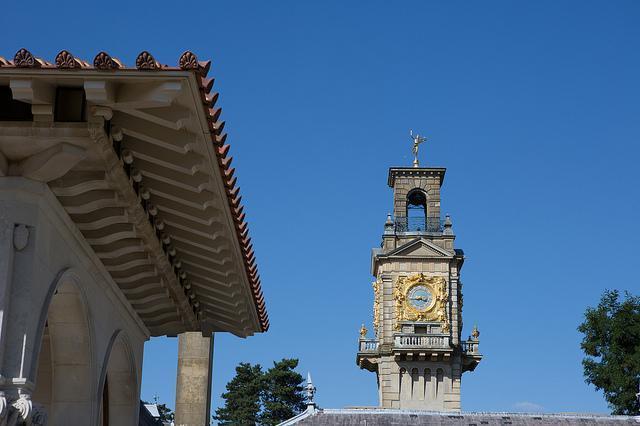How many arches are there in the scene?
Give a very brief answer. 3. How many people are wearing orange jackets?
Give a very brief answer. 0. 